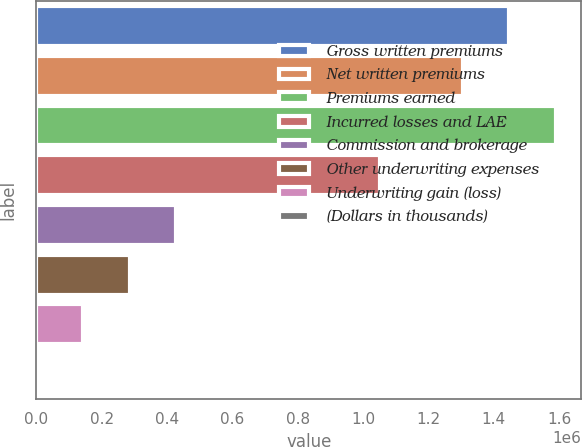Convert chart to OTSL. <chart><loc_0><loc_0><loc_500><loc_500><bar_chart><fcel>Gross written premiums<fcel>Net written premiums<fcel>Premiums earned<fcel>Incurred losses and LAE<fcel>Commission and brokerage<fcel>Other underwriting expenses<fcel>Underwriting gain (loss)<fcel>(Dollars in thousands)<nl><fcel>1.4479e+06<fcel>1.30646e+06<fcel>1.58934e+06<fcel>1.05039e+06<fcel>426330<fcel>284891<fcel>143452<fcel>2012<nl></chart> 